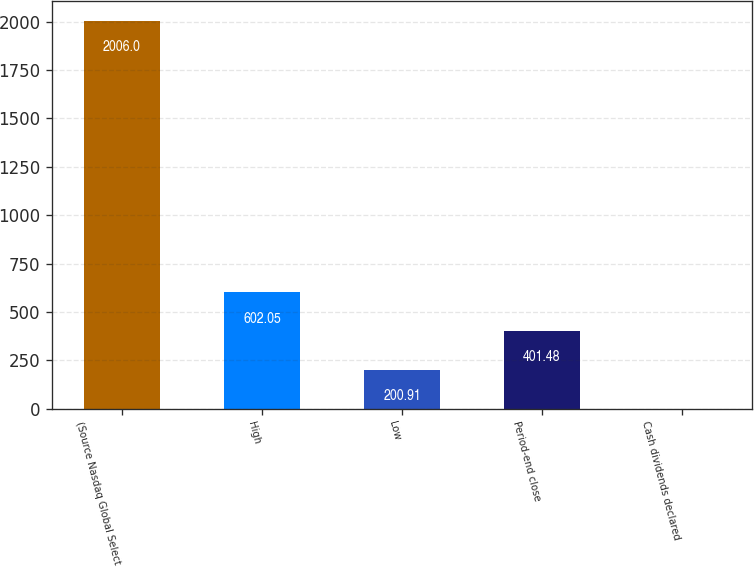<chart> <loc_0><loc_0><loc_500><loc_500><bar_chart><fcel>(Source Nasdaq Global Select<fcel>High<fcel>Low<fcel>Period-end close<fcel>Cash dividends declared<nl><fcel>2006<fcel>602.05<fcel>200.91<fcel>401.48<fcel>0.34<nl></chart> 